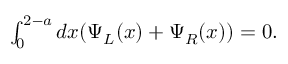<formula> <loc_0><loc_0><loc_500><loc_500>\begin{array} { r } { \int _ { 0 } ^ { 2 - a } d x ( \Psi _ { L } ( x ) + \Psi _ { R } ( x ) ) = 0 . } \end{array}</formula> 